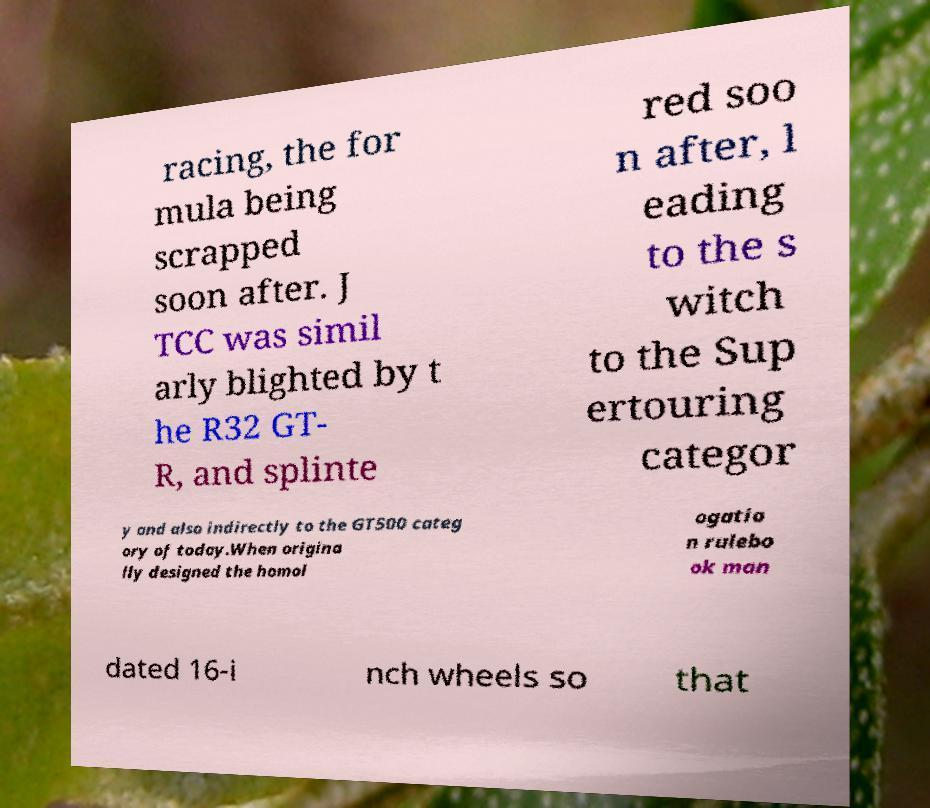Can you read and provide the text displayed in the image?This photo seems to have some interesting text. Can you extract and type it out for me? racing, the for mula being scrapped soon after. J TCC was simil arly blighted by t he R32 GT- R, and splinte red soo n after, l eading to the s witch to the Sup ertouring categor y and also indirectly to the GT500 categ ory of today.When origina lly designed the homol ogatio n rulebo ok man dated 16-i nch wheels so that 